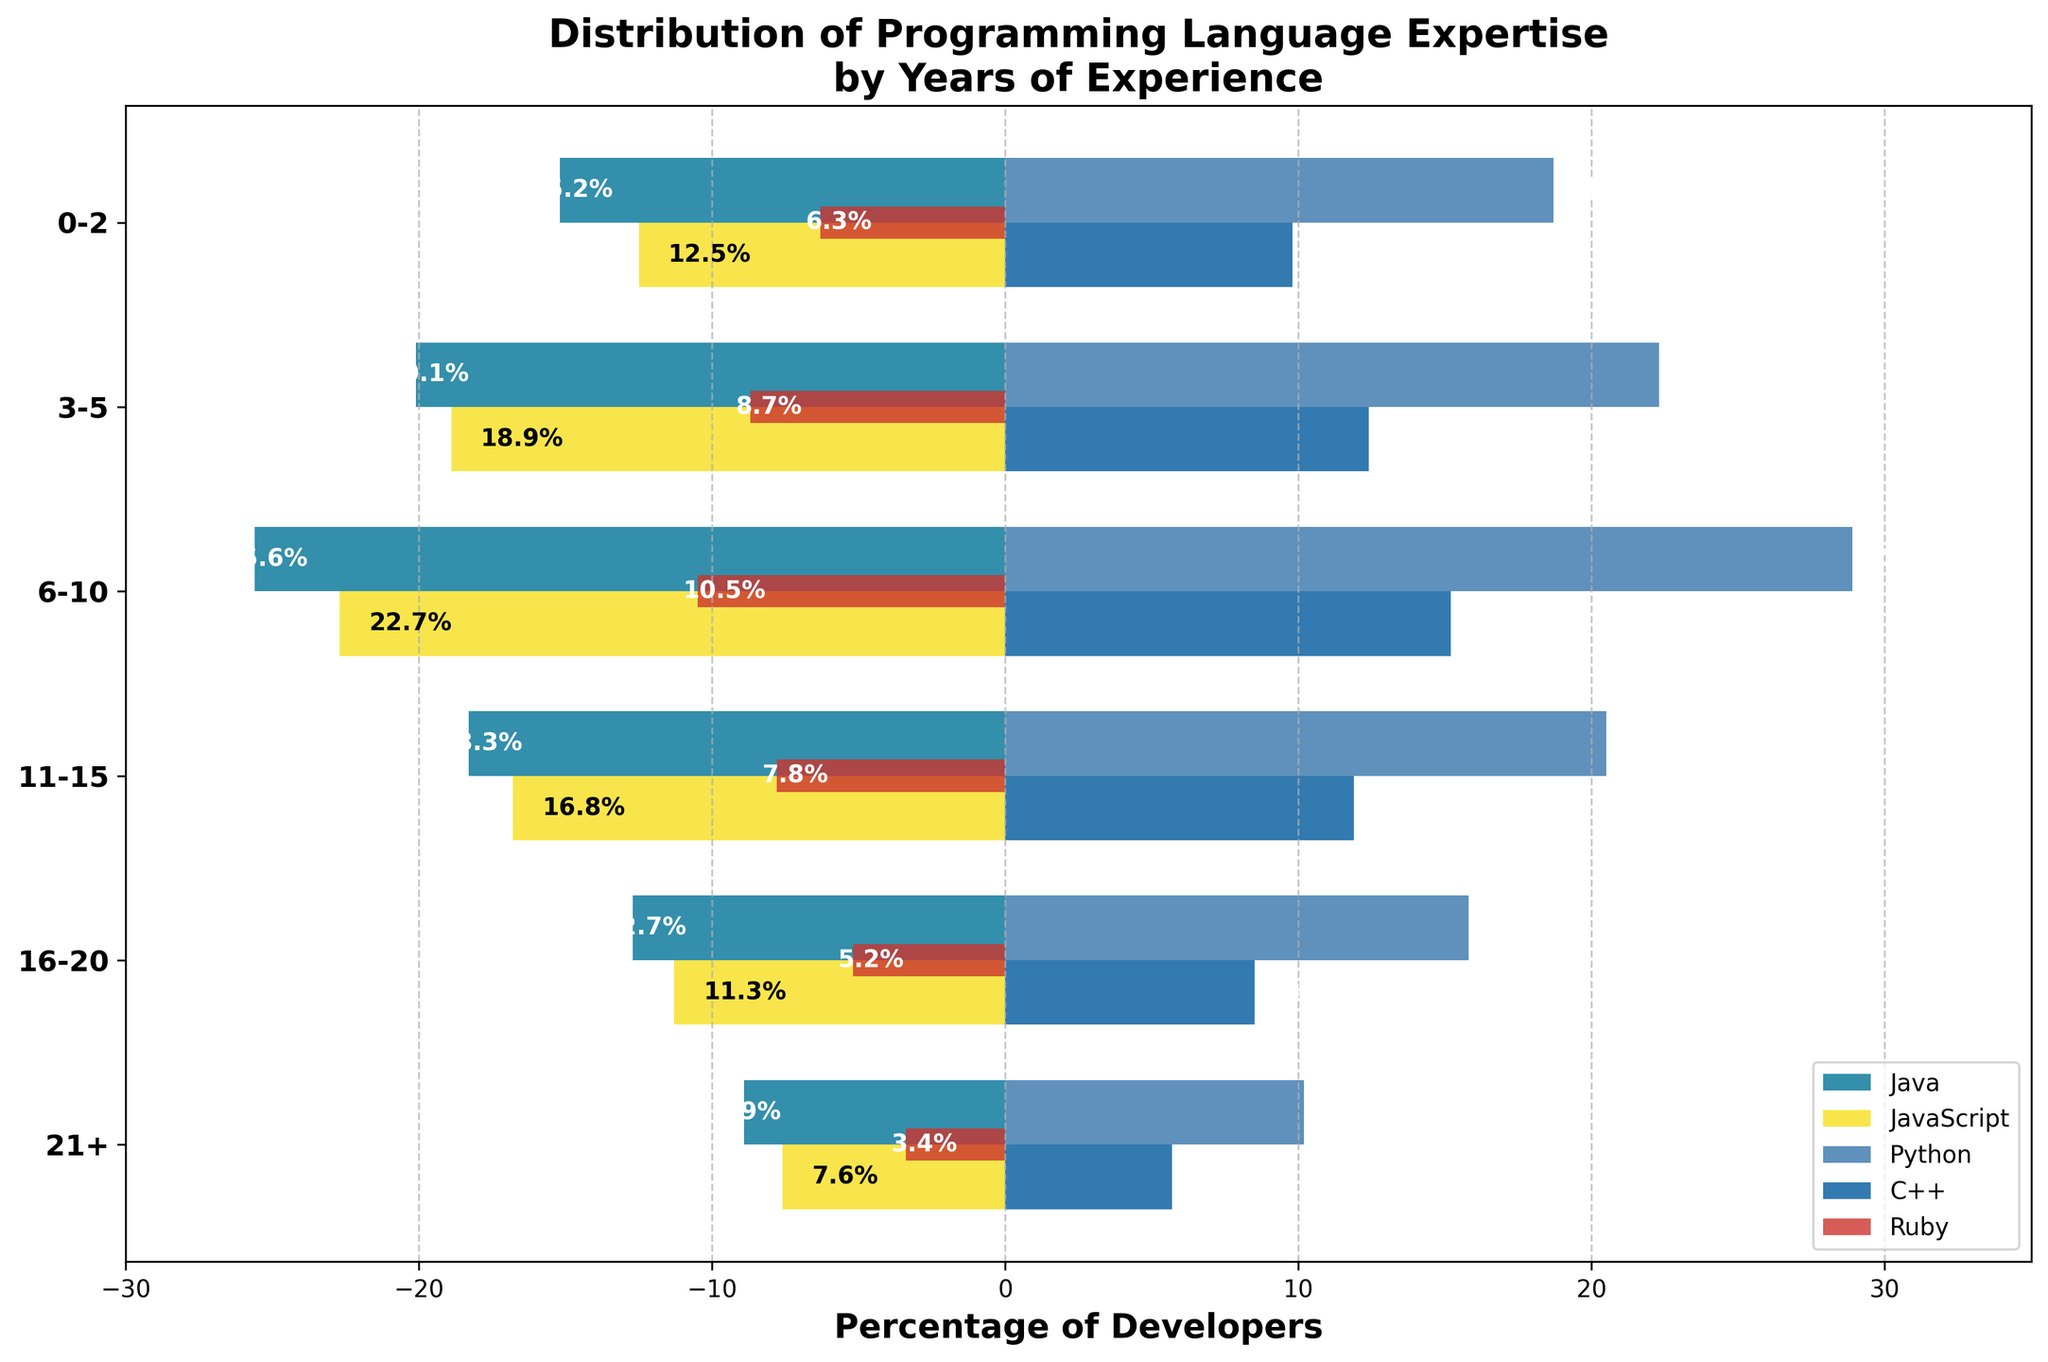What is the title of the figure? The title of the figure is typically placed at the top and indicates what the figure is about. In this case, it mentions "Distribution of Programming Language Expertise by Years of Experience".
Answer: Distribution of Programming Language Expertise by Years of Experience Which programming language has the highest percentage of developers with 6-10 years of experience? Observe the bars for the 6-10 years category and identify the highest value. The Python bar extends furthest to the right, indicating it has the highest percentage.
Answer: Python Which programming language has the fewest developers with 21+ years of experience? Look at the bars for the 21+ years category and determine which one is the shortest bar. The Ruby bar is the shortest.
Answer: Ruby What is the difference between the percentage of Python and Java developers with 3-5 years of experience? The bars for 3-5 years show Python at 22.3% and Java at -20.1%. Calculate the absolute difference: 22.3 - (-20.1) = 42.4%.
Answer: 42.4% How does the trend for Java developers change from 0-2 years to 21+ years? Notice the bar lengths for Java across different categories. Java starts from -15.2% for 0-2 years and gradually decreases to -8.9% for 21+ years, indicating a decreasing trend.
Answer: Decreasing Which age group has the highest percentage of developers in C++? Identify the bar for C++ that extends furthest to the right. This occurs in the 6-10 years category with a percentage of 15.2%.
Answer: 6-10 years How does the distribution of JavaScript developers differ from Java developers over the years? Compare the bars of JavaScript and Java across all experience categories. JavaScript percentages are generally negative and decrease more significantly compared to Java, which also shows a decreasing trend but starts from a higher negative value.
Answer: JavaScript decreases more significantly What can we infer about Ruby developers' experience distribution? Looking at the bars for Ruby in all categories, Ruby has a consistent negative representation, and its bar lengths are considerably shorter compared to other languages, indicating fewer developers prefer Ruby across different experience levels.
Answer: Fewer developers prefer Ruby What is the total percentage of Python developers across all experience levels? Sum the positive percentages for Python across all categories: 18.7 + 22.3 + 28.9 + 20.5 + 15.8 + 10.2 = 116.4%.
Answer: 116.4% Which programming languages show a positive trend and which show a negative trend as years of experience increase? Assess each language's bar from left to right. Python and C++ have positive percentages that indicate higher expertise with increasing years. Languages like Java and JavaScript show decreasing percentages and negative values. Ruby consistently has negative values but fewer developers in all ranges.
Answer: Python and C++ show positive trends; Java, JavaScript, and Ruby show negative trends 